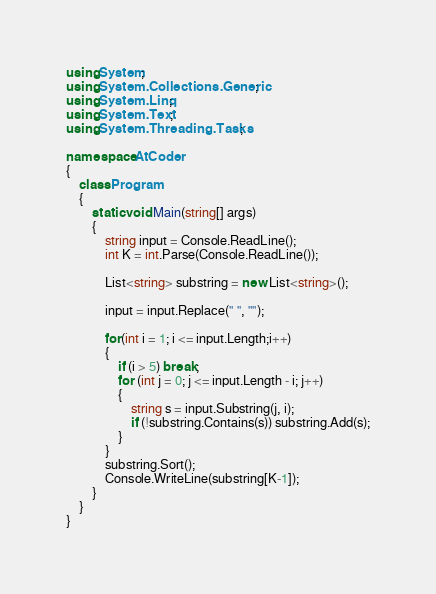<code> <loc_0><loc_0><loc_500><loc_500><_C#_>using System;
using System.Collections.Generic;
using System.Linq;
using System.Text;
using System.Threading.Tasks;

namespace AtCoder
{
    class Program
    {
        static void Main(string[] args)
        {
            string input = Console.ReadLine();
            int K = int.Parse(Console.ReadLine());

            List<string> substring = new List<string>();

            input = input.Replace(" ", "");

            for(int i = 1; i <= input.Length;i++)
            {
                if (i > 5) break;
                for (int j = 0; j <= input.Length - i; j++)
                {
                    string s = input.Substring(j, i);
                    if (!substring.Contains(s)) substring.Add(s);
                }
            }
            substring.Sort();
            Console.WriteLine(substring[K-1]);
        }
    }
}
</code> 